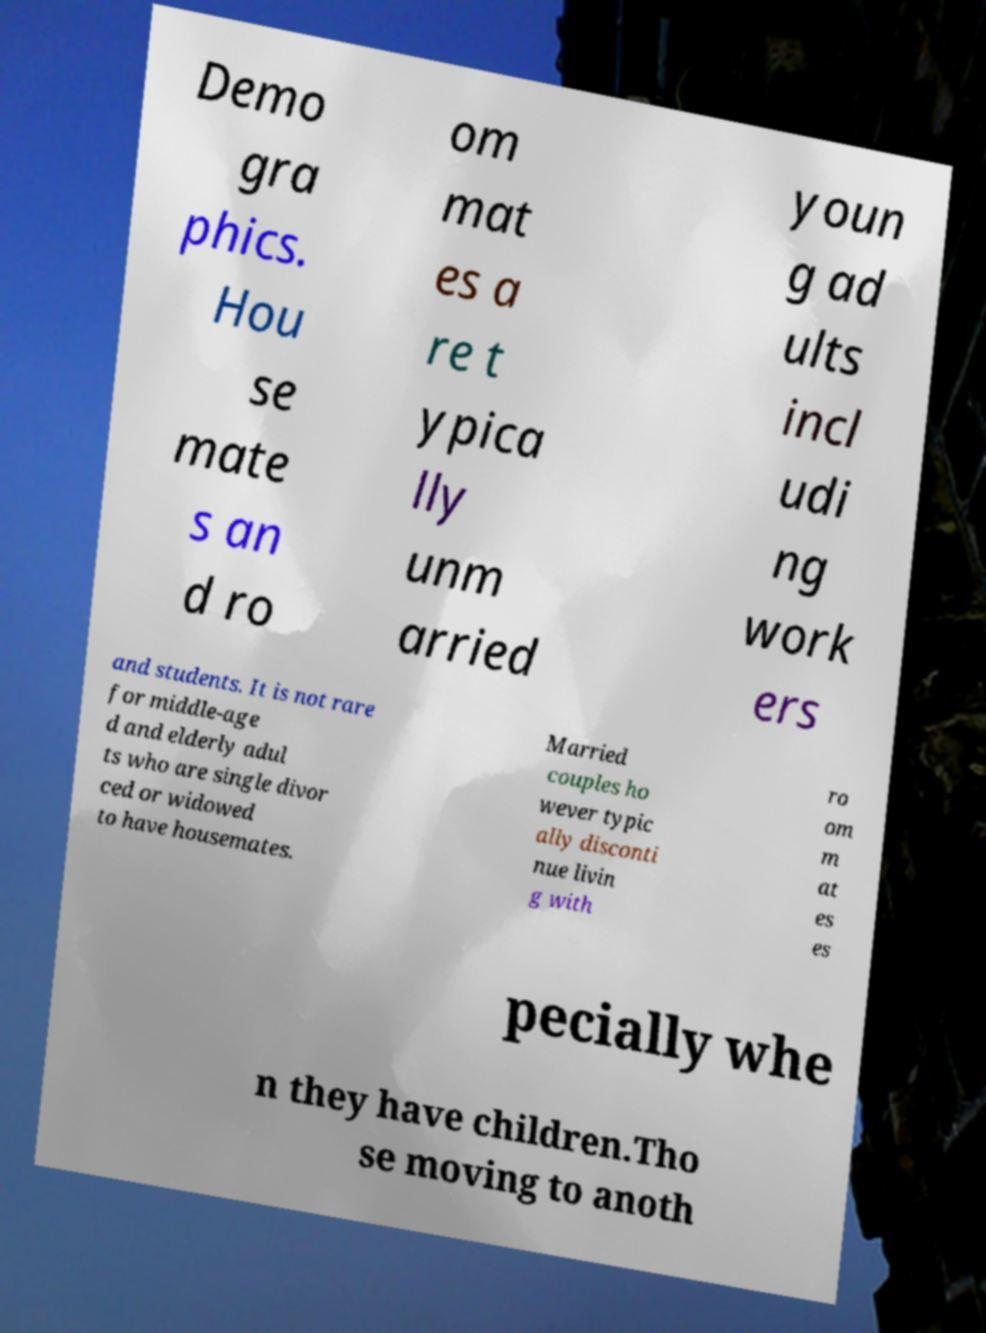There's text embedded in this image that I need extracted. Can you transcribe it verbatim? Demo gra phics. Hou se mate s an d ro om mat es a re t ypica lly unm arried youn g ad ults incl udi ng work ers and students. It is not rare for middle-age d and elderly adul ts who are single divor ced or widowed to have housemates. Married couples ho wever typic ally disconti nue livin g with ro om m at es es pecially whe n they have children.Tho se moving to anoth 